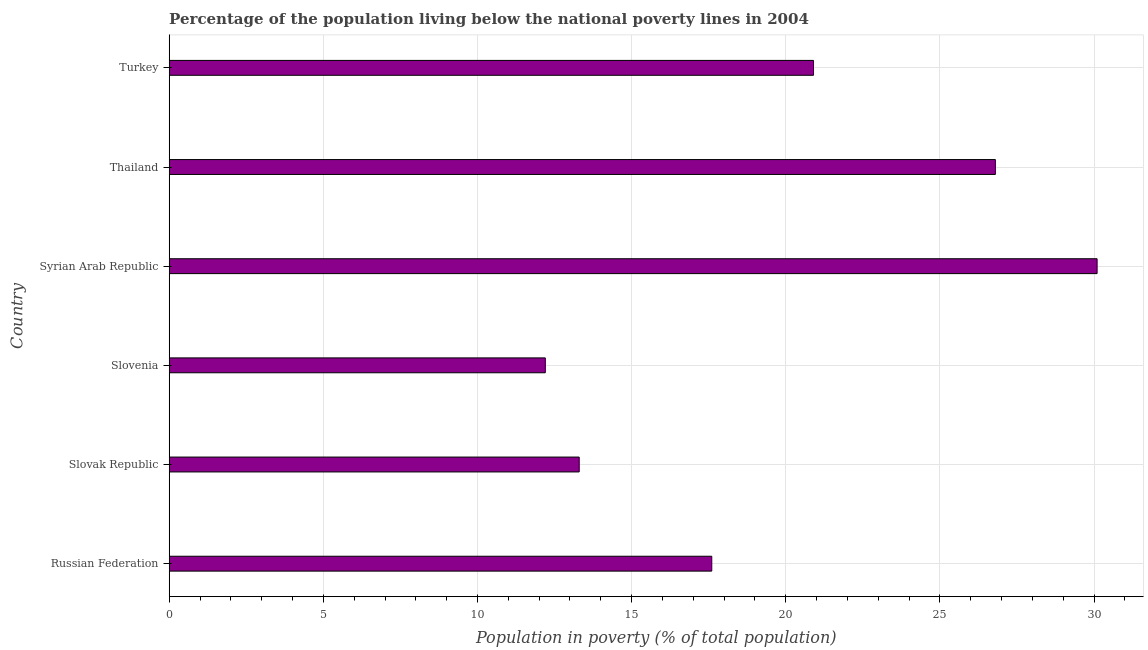Does the graph contain grids?
Provide a succinct answer. Yes. What is the title of the graph?
Offer a terse response. Percentage of the population living below the national poverty lines in 2004. What is the label or title of the X-axis?
Provide a short and direct response. Population in poverty (% of total population). What is the label or title of the Y-axis?
Make the answer very short. Country. What is the percentage of population living below poverty line in Slovenia?
Make the answer very short. 12.2. Across all countries, what is the maximum percentage of population living below poverty line?
Your answer should be very brief. 30.1. In which country was the percentage of population living below poverty line maximum?
Provide a short and direct response. Syrian Arab Republic. In which country was the percentage of population living below poverty line minimum?
Make the answer very short. Slovenia. What is the sum of the percentage of population living below poverty line?
Make the answer very short. 120.9. What is the difference between the percentage of population living below poverty line in Russian Federation and Turkey?
Provide a succinct answer. -3.3. What is the average percentage of population living below poverty line per country?
Your answer should be very brief. 20.15. What is the median percentage of population living below poverty line?
Your response must be concise. 19.25. In how many countries, is the percentage of population living below poverty line greater than 30 %?
Your response must be concise. 1. What is the ratio of the percentage of population living below poverty line in Russian Federation to that in Thailand?
Provide a short and direct response. 0.66. Is the difference between the percentage of population living below poverty line in Russian Federation and Turkey greater than the difference between any two countries?
Offer a very short reply. No. What is the difference between the highest and the second highest percentage of population living below poverty line?
Give a very brief answer. 3.3. Is the sum of the percentage of population living below poverty line in Slovak Republic and Thailand greater than the maximum percentage of population living below poverty line across all countries?
Make the answer very short. Yes. What is the difference between the highest and the lowest percentage of population living below poverty line?
Offer a terse response. 17.9. In how many countries, is the percentage of population living below poverty line greater than the average percentage of population living below poverty line taken over all countries?
Give a very brief answer. 3. How many bars are there?
Your response must be concise. 6. What is the difference between two consecutive major ticks on the X-axis?
Your response must be concise. 5. What is the Population in poverty (% of total population) in Slovak Republic?
Give a very brief answer. 13.3. What is the Population in poverty (% of total population) of Syrian Arab Republic?
Provide a short and direct response. 30.1. What is the Population in poverty (% of total population) of Thailand?
Offer a terse response. 26.8. What is the Population in poverty (% of total population) of Turkey?
Keep it short and to the point. 20.9. What is the difference between the Population in poverty (% of total population) in Russian Federation and Slovak Republic?
Keep it short and to the point. 4.3. What is the difference between the Population in poverty (% of total population) in Russian Federation and Syrian Arab Republic?
Provide a short and direct response. -12.5. What is the difference between the Population in poverty (% of total population) in Russian Federation and Turkey?
Your response must be concise. -3.3. What is the difference between the Population in poverty (% of total population) in Slovak Republic and Syrian Arab Republic?
Your answer should be compact. -16.8. What is the difference between the Population in poverty (% of total population) in Slovak Republic and Turkey?
Keep it short and to the point. -7.6. What is the difference between the Population in poverty (% of total population) in Slovenia and Syrian Arab Republic?
Provide a succinct answer. -17.9. What is the difference between the Population in poverty (% of total population) in Slovenia and Thailand?
Your answer should be compact. -14.6. What is the difference between the Population in poverty (% of total population) in Syrian Arab Republic and Thailand?
Your response must be concise. 3.3. What is the difference between the Population in poverty (% of total population) in Syrian Arab Republic and Turkey?
Provide a short and direct response. 9.2. What is the ratio of the Population in poverty (% of total population) in Russian Federation to that in Slovak Republic?
Ensure brevity in your answer.  1.32. What is the ratio of the Population in poverty (% of total population) in Russian Federation to that in Slovenia?
Your response must be concise. 1.44. What is the ratio of the Population in poverty (% of total population) in Russian Federation to that in Syrian Arab Republic?
Your response must be concise. 0.58. What is the ratio of the Population in poverty (% of total population) in Russian Federation to that in Thailand?
Give a very brief answer. 0.66. What is the ratio of the Population in poverty (% of total population) in Russian Federation to that in Turkey?
Provide a short and direct response. 0.84. What is the ratio of the Population in poverty (% of total population) in Slovak Republic to that in Slovenia?
Your answer should be compact. 1.09. What is the ratio of the Population in poverty (% of total population) in Slovak Republic to that in Syrian Arab Republic?
Offer a terse response. 0.44. What is the ratio of the Population in poverty (% of total population) in Slovak Republic to that in Thailand?
Ensure brevity in your answer.  0.5. What is the ratio of the Population in poverty (% of total population) in Slovak Republic to that in Turkey?
Offer a terse response. 0.64. What is the ratio of the Population in poverty (% of total population) in Slovenia to that in Syrian Arab Republic?
Keep it short and to the point. 0.41. What is the ratio of the Population in poverty (% of total population) in Slovenia to that in Thailand?
Offer a very short reply. 0.46. What is the ratio of the Population in poverty (% of total population) in Slovenia to that in Turkey?
Provide a short and direct response. 0.58. What is the ratio of the Population in poverty (% of total population) in Syrian Arab Republic to that in Thailand?
Make the answer very short. 1.12. What is the ratio of the Population in poverty (% of total population) in Syrian Arab Republic to that in Turkey?
Ensure brevity in your answer.  1.44. What is the ratio of the Population in poverty (% of total population) in Thailand to that in Turkey?
Give a very brief answer. 1.28. 